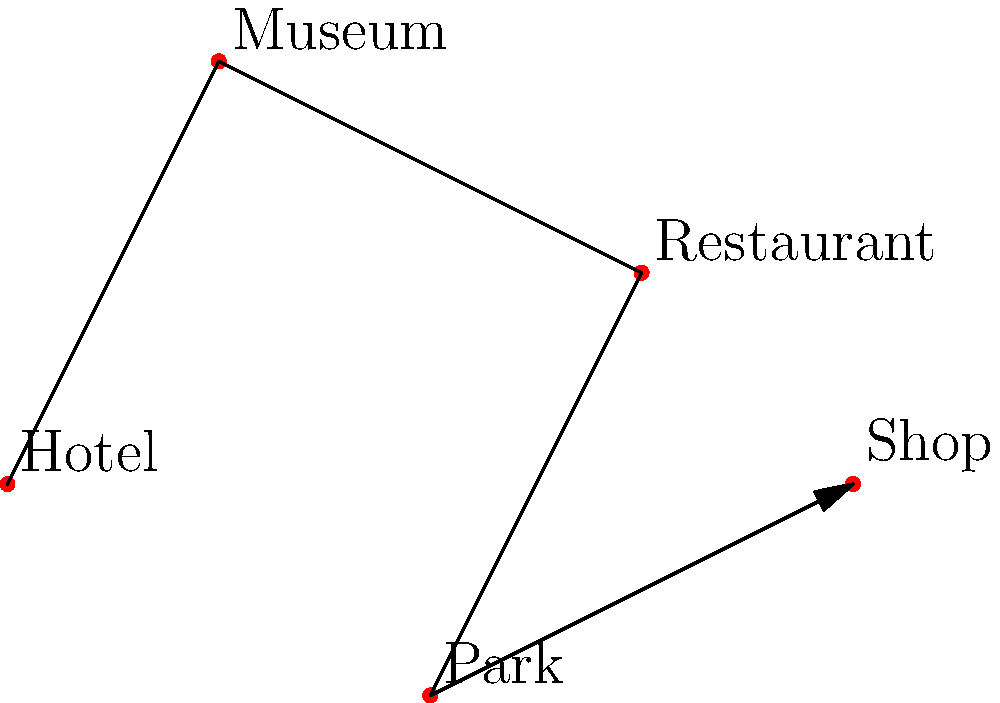As a tourist, you want to visit all the locations shown in the map efficiently. Starting from your hotel, what is the optimal order to visit the museum, restaurant, park, and shop to minimize travel distance? To determine the optimal route, we need to analyze the relative positions of each location:

1. Start at the Hotel (0,0)
2. The closest location is the Museum (1,2)
3. From the Museum, the Restaurant (3,1) is the nearest point
4. After the Restaurant, the Park (2,-1) is closer than the Shop
5. Finally, end at the Shop (4,0)

This route minimizes the total distance traveled between locations, creating an efficient sightseeing path.
Answer: Hotel → Museum → Restaurant → Park → Shop 